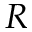<formula> <loc_0><loc_0><loc_500><loc_500>R</formula> 